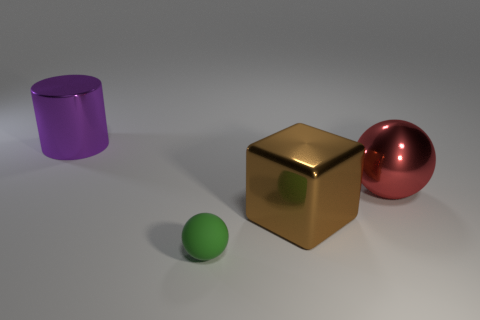Subtract all cyan balls. Subtract all red blocks. How many balls are left? 2 Subtract all gray cylinders. How many purple spheres are left? 0 Add 2 greens. How many objects exist? 0 Subtract all large gray metal cubes. Subtract all brown cubes. How many objects are left? 3 Add 3 large brown things. How many large brown things are left? 4 Add 3 big shiny cubes. How many big shiny cubes exist? 4 Add 4 big things. How many objects exist? 8 Subtract all red balls. How many balls are left? 1 Subtract 0 cyan cylinders. How many objects are left? 4 Subtract all cylinders. How many objects are left? 3 